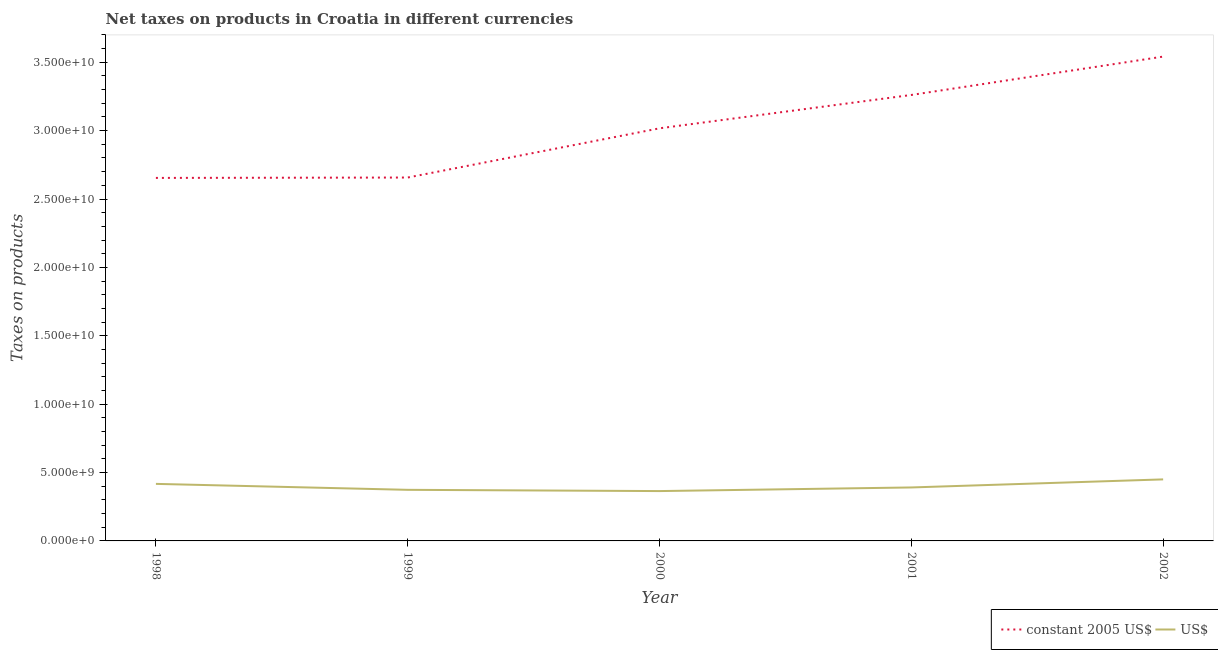How many different coloured lines are there?
Ensure brevity in your answer.  2. What is the net taxes in constant 2005 us$ in 1999?
Make the answer very short. 2.66e+1. Across all years, what is the maximum net taxes in constant 2005 us$?
Give a very brief answer. 3.54e+1. Across all years, what is the minimum net taxes in constant 2005 us$?
Offer a terse response. 2.65e+1. In which year was the net taxes in us$ maximum?
Provide a short and direct response. 2002. In which year was the net taxes in constant 2005 us$ minimum?
Provide a succinct answer. 1998. What is the total net taxes in constant 2005 us$ in the graph?
Give a very brief answer. 1.51e+11. What is the difference between the net taxes in constant 2005 us$ in 2000 and that in 2002?
Keep it short and to the point. -5.24e+09. What is the difference between the net taxes in constant 2005 us$ in 1998 and the net taxes in us$ in 2001?
Provide a short and direct response. 2.26e+1. What is the average net taxes in constant 2005 us$ per year?
Your response must be concise. 3.03e+1. In the year 1999, what is the difference between the net taxes in us$ and net taxes in constant 2005 us$?
Offer a very short reply. -2.28e+1. In how many years, is the net taxes in constant 2005 us$ greater than 25000000000 units?
Provide a short and direct response. 5. What is the ratio of the net taxes in constant 2005 us$ in 1998 to that in 1999?
Offer a terse response. 1. What is the difference between the highest and the second highest net taxes in us$?
Keep it short and to the point. 3.28e+08. What is the difference between the highest and the lowest net taxes in constant 2005 us$?
Offer a very short reply. 8.87e+09. In how many years, is the net taxes in us$ greater than the average net taxes in us$ taken over all years?
Ensure brevity in your answer.  2. Is the sum of the net taxes in constant 2005 us$ in 2001 and 2002 greater than the maximum net taxes in us$ across all years?
Provide a short and direct response. Yes. Does the net taxes in us$ monotonically increase over the years?
Give a very brief answer. No. How many years are there in the graph?
Your response must be concise. 5. What is the difference between two consecutive major ticks on the Y-axis?
Offer a very short reply. 5.00e+09. Does the graph contain grids?
Offer a very short reply. No. How many legend labels are there?
Your response must be concise. 2. How are the legend labels stacked?
Ensure brevity in your answer.  Horizontal. What is the title of the graph?
Make the answer very short. Net taxes on products in Croatia in different currencies. Does "Taxes" appear as one of the legend labels in the graph?
Offer a terse response. No. What is the label or title of the X-axis?
Provide a succinct answer. Year. What is the label or title of the Y-axis?
Your response must be concise. Taxes on products. What is the Taxes on products in constant 2005 US$ in 1998?
Provide a short and direct response. 2.65e+1. What is the Taxes on products in US$ in 1998?
Give a very brief answer. 4.17e+09. What is the Taxes on products of constant 2005 US$ in 1999?
Provide a short and direct response. 2.66e+1. What is the Taxes on products of US$ in 1999?
Your answer should be very brief. 3.74e+09. What is the Taxes on products of constant 2005 US$ in 2000?
Ensure brevity in your answer.  3.02e+1. What is the Taxes on products in US$ in 2000?
Keep it short and to the point. 3.64e+09. What is the Taxes on products in constant 2005 US$ in 2001?
Ensure brevity in your answer.  3.26e+1. What is the Taxes on products of US$ in 2001?
Provide a short and direct response. 3.91e+09. What is the Taxes on products in constant 2005 US$ in 2002?
Your answer should be compact. 3.54e+1. What is the Taxes on products of US$ in 2002?
Keep it short and to the point. 4.50e+09. Across all years, what is the maximum Taxes on products in constant 2005 US$?
Your answer should be very brief. 3.54e+1. Across all years, what is the maximum Taxes on products of US$?
Keep it short and to the point. 4.50e+09. Across all years, what is the minimum Taxes on products of constant 2005 US$?
Give a very brief answer. 2.65e+1. Across all years, what is the minimum Taxes on products of US$?
Keep it short and to the point. 3.64e+09. What is the total Taxes on products of constant 2005 US$ in the graph?
Give a very brief answer. 1.51e+11. What is the total Taxes on products in US$ in the graph?
Your response must be concise. 2.00e+1. What is the difference between the Taxes on products in constant 2005 US$ in 1998 and that in 1999?
Offer a very short reply. -2.80e+07. What is the difference between the Taxes on products in US$ in 1998 and that in 1999?
Your response must be concise. 4.35e+08. What is the difference between the Taxes on products in constant 2005 US$ in 1998 and that in 2000?
Your response must be concise. -3.63e+09. What is the difference between the Taxes on products in US$ in 1998 and that in 2000?
Ensure brevity in your answer.  5.27e+08. What is the difference between the Taxes on products in constant 2005 US$ in 1998 and that in 2001?
Make the answer very short. -6.07e+09. What is the difference between the Taxes on products in US$ in 1998 and that in 2001?
Your answer should be very brief. 2.62e+08. What is the difference between the Taxes on products in constant 2005 US$ in 1998 and that in 2002?
Give a very brief answer. -8.87e+09. What is the difference between the Taxes on products in US$ in 1998 and that in 2002?
Keep it short and to the point. -3.28e+08. What is the difference between the Taxes on products in constant 2005 US$ in 1999 and that in 2000?
Provide a short and direct response. -3.60e+09. What is the difference between the Taxes on products of US$ in 1999 and that in 2000?
Your response must be concise. 9.15e+07. What is the difference between the Taxes on products of constant 2005 US$ in 1999 and that in 2001?
Provide a short and direct response. -6.04e+09. What is the difference between the Taxes on products of US$ in 1999 and that in 2001?
Your answer should be compact. -1.73e+08. What is the difference between the Taxes on products in constant 2005 US$ in 1999 and that in 2002?
Your response must be concise. -8.84e+09. What is the difference between the Taxes on products of US$ in 1999 and that in 2002?
Offer a very short reply. -7.63e+08. What is the difference between the Taxes on products in constant 2005 US$ in 2000 and that in 2001?
Offer a very short reply. -2.44e+09. What is the difference between the Taxes on products in US$ in 2000 and that in 2001?
Keep it short and to the point. -2.65e+08. What is the difference between the Taxes on products in constant 2005 US$ in 2000 and that in 2002?
Provide a short and direct response. -5.24e+09. What is the difference between the Taxes on products in US$ in 2000 and that in 2002?
Offer a terse response. -8.54e+08. What is the difference between the Taxes on products of constant 2005 US$ in 2001 and that in 2002?
Offer a very short reply. -2.80e+09. What is the difference between the Taxes on products of US$ in 2001 and that in 2002?
Make the answer very short. -5.90e+08. What is the difference between the Taxes on products in constant 2005 US$ in 1998 and the Taxes on products in US$ in 1999?
Provide a succinct answer. 2.28e+1. What is the difference between the Taxes on products of constant 2005 US$ in 1998 and the Taxes on products of US$ in 2000?
Offer a very short reply. 2.29e+1. What is the difference between the Taxes on products of constant 2005 US$ in 1998 and the Taxes on products of US$ in 2001?
Keep it short and to the point. 2.26e+1. What is the difference between the Taxes on products of constant 2005 US$ in 1998 and the Taxes on products of US$ in 2002?
Your answer should be very brief. 2.20e+1. What is the difference between the Taxes on products in constant 2005 US$ in 1999 and the Taxes on products in US$ in 2000?
Make the answer very short. 2.29e+1. What is the difference between the Taxes on products of constant 2005 US$ in 1999 and the Taxes on products of US$ in 2001?
Your answer should be compact. 2.27e+1. What is the difference between the Taxes on products in constant 2005 US$ in 1999 and the Taxes on products in US$ in 2002?
Ensure brevity in your answer.  2.21e+1. What is the difference between the Taxes on products of constant 2005 US$ in 2000 and the Taxes on products of US$ in 2001?
Make the answer very short. 2.63e+1. What is the difference between the Taxes on products in constant 2005 US$ in 2000 and the Taxes on products in US$ in 2002?
Your answer should be very brief. 2.57e+1. What is the difference between the Taxes on products in constant 2005 US$ in 2001 and the Taxes on products in US$ in 2002?
Provide a short and direct response. 2.81e+1. What is the average Taxes on products in constant 2005 US$ per year?
Keep it short and to the point. 3.03e+1. What is the average Taxes on products of US$ per year?
Your answer should be very brief. 3.99e+09. In the year 1998, what is the difference between the Taxes on products of constant 2005 US$ and Taxes on products of US$?
Your answer should be compact. 2.24e+1. In the year 1999, what is the difference between the Taxes on products in constant 2005 US$ and Taxes on products in US$?
Provide a short and direct response. 2.28e+1. In the year 2000, what is the difference between the Taxes on products in constant 2005 US$ and Taxes on products in US$?
Your answer should be very brief. 2.65e+1. In the year 2001, what is the difference between the Taxes on products of constant 2005 US$ and Taxes on products of US$?
Ensure brevity in your answer.  2.87e+1. In the year 2002, what is the difference between the Taxes on products of constant 2005 US$ and Taxes on products of US$?
Give a very brief answer. 3.09e+1. What is the ratio of the Taxes on products of constant 2005 US$ in 1998 to that in 1999?
Give a very brief answer. 1. What is the ratio of the Taxes on products of US$ in 1998 to that in 1999?
Your response must be concise. 1.12. What is the ratio of the Taxes on products in constant 2005 US$ in 1998 to that in 2000?
Give a very brief answer. 0.88. What is the ratio of the Taxes on products of US$ in 1998 to that in 2000?
Make the answer very short. 1.14. What is the ratio of the Taxes on products in constant 2005 US$ in 1998 to that in 2001?
Your response must be concise. 0.81. What is the ratio of the Taxes on products of US$ in 1998 to that in 2001?
Offer a terse response. 1.07. What is the ratio of the Taxes on products in constant 2005 US$ in 1998 to that in 2002?
Your response must be concise. 0.75. What is the ratio of the Taxes on products of US$ in 1998 to that in 2002?
Your answer should be very brief. 0.93. What is the ratio of the Taxes on products of constant 2005 US$ in 1999 to that in 2000?
Offer a very short reply. 0.88. What is the ratio of the Taxes on products of US$ in 1999 to that in 2000?
Keep it short and to the point. 1.03. What is the ratio of the Taxes on products of constant 2005 US$ in 1999 to that in 2001?
Provide a short and direct response. 0.81. What is the ratio of the Taxes on products in US$ in 1999 to that in 2001?
Keep it short and to the point. 0.96. What is the ratio of the Taxes on products in constant 2005 US$ in 1999 to that in 2002?
Your answer should be compact. 0.75. What is the ratio of the Taxes on products in US$ in 1999 to that in 2002?
Provide a short and direct response. 0.83. What is the ratio of the Taxes on products of constant 2005 US$ in 2000 to that in 2001?
Your response must be concise. 0.93. What is the ratio of the Taxes on products of US$ in 2000 to that in 2001?
Your answer should be compact. 0.93. What is the ratio of the Taxes on products of constant 2005 US$ in 2000 to that in 2002?
Provide a short and direct response. 0.85. What is the ratio of the Taxes on products of US$ in 2000 to that in 2002?
Provide a short and direct response. 0.81. What is the ratio of the Taxes on products in constant 2005 US$ in 2001 to that in 2002?
Provide a succinct answer. 0.92. What is the ratio of the Taxes on products in US$ in 2001 to that in 2002?
Your answer should be compact. 0.87. What is the difference between the highest and the second highest Taxes on products of constant 2005 US$?
Ensure brevity in your answer.  2.80e+09. What is the difference between the highest and the second highest Taxes on products in US$?
Make the answer very short. 3.28e+08. What is the difference between the highest and the lowest Taxes on products in constant 2005 US$?
Your answer should be compact. 8.87e+09. What is the difference between the highest and the lowest Taxes on products in US$?
Your answer should be compact. 8.54e+08. 